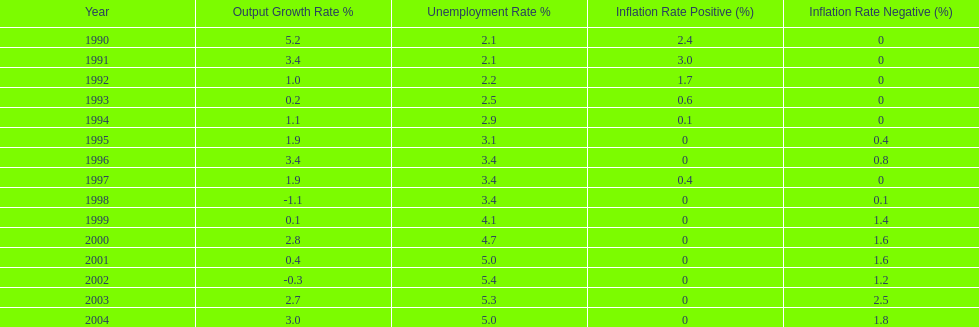What year saw the highest output growth rate in japan between the years 1990 and 2004? 1990. Help me parse the entirety of this table. {'header': ['Year', 'Output Growth Rate\xa0%', 'Unemployment Rate\xa0%', 'Inflation Rate Positive (%)', 'Inflation Rate Negative (%)'], 'rows': [['1990', '5.2', '2.1', '2.4', '0'], ['1991', '3.4', '2.1', '3.0', '0'], ['1992', '1.0', '2.2', '1.7', '0'], ['1993', '0.2', '2.5', '0.6', '0'], ['1994', '1.1', '2.9', '0.1', '0'], ['1995', '1.9', '3.1', '0', '0.4'], ['1996', '3.4', '3.4', '0', '0.8'], ['1997', '1.9', '3.4', '0.4', '0'], ['1998', '-1.1', '3.4', '0', '0.1'], ['1999', '0.1', '4.1', '0', '1.4'], ['2000', '2.8', '4.7', '0', '1.6'], ['2001', '0.4', '5.0', '0', '1.6'], ['2002', '-0.3', '5.4', '0', '1.2'], ['2003', '2.7', '5.3', '0', '2.5'], ['2004', '3.0', '5.0', '0', '1.8']]} 